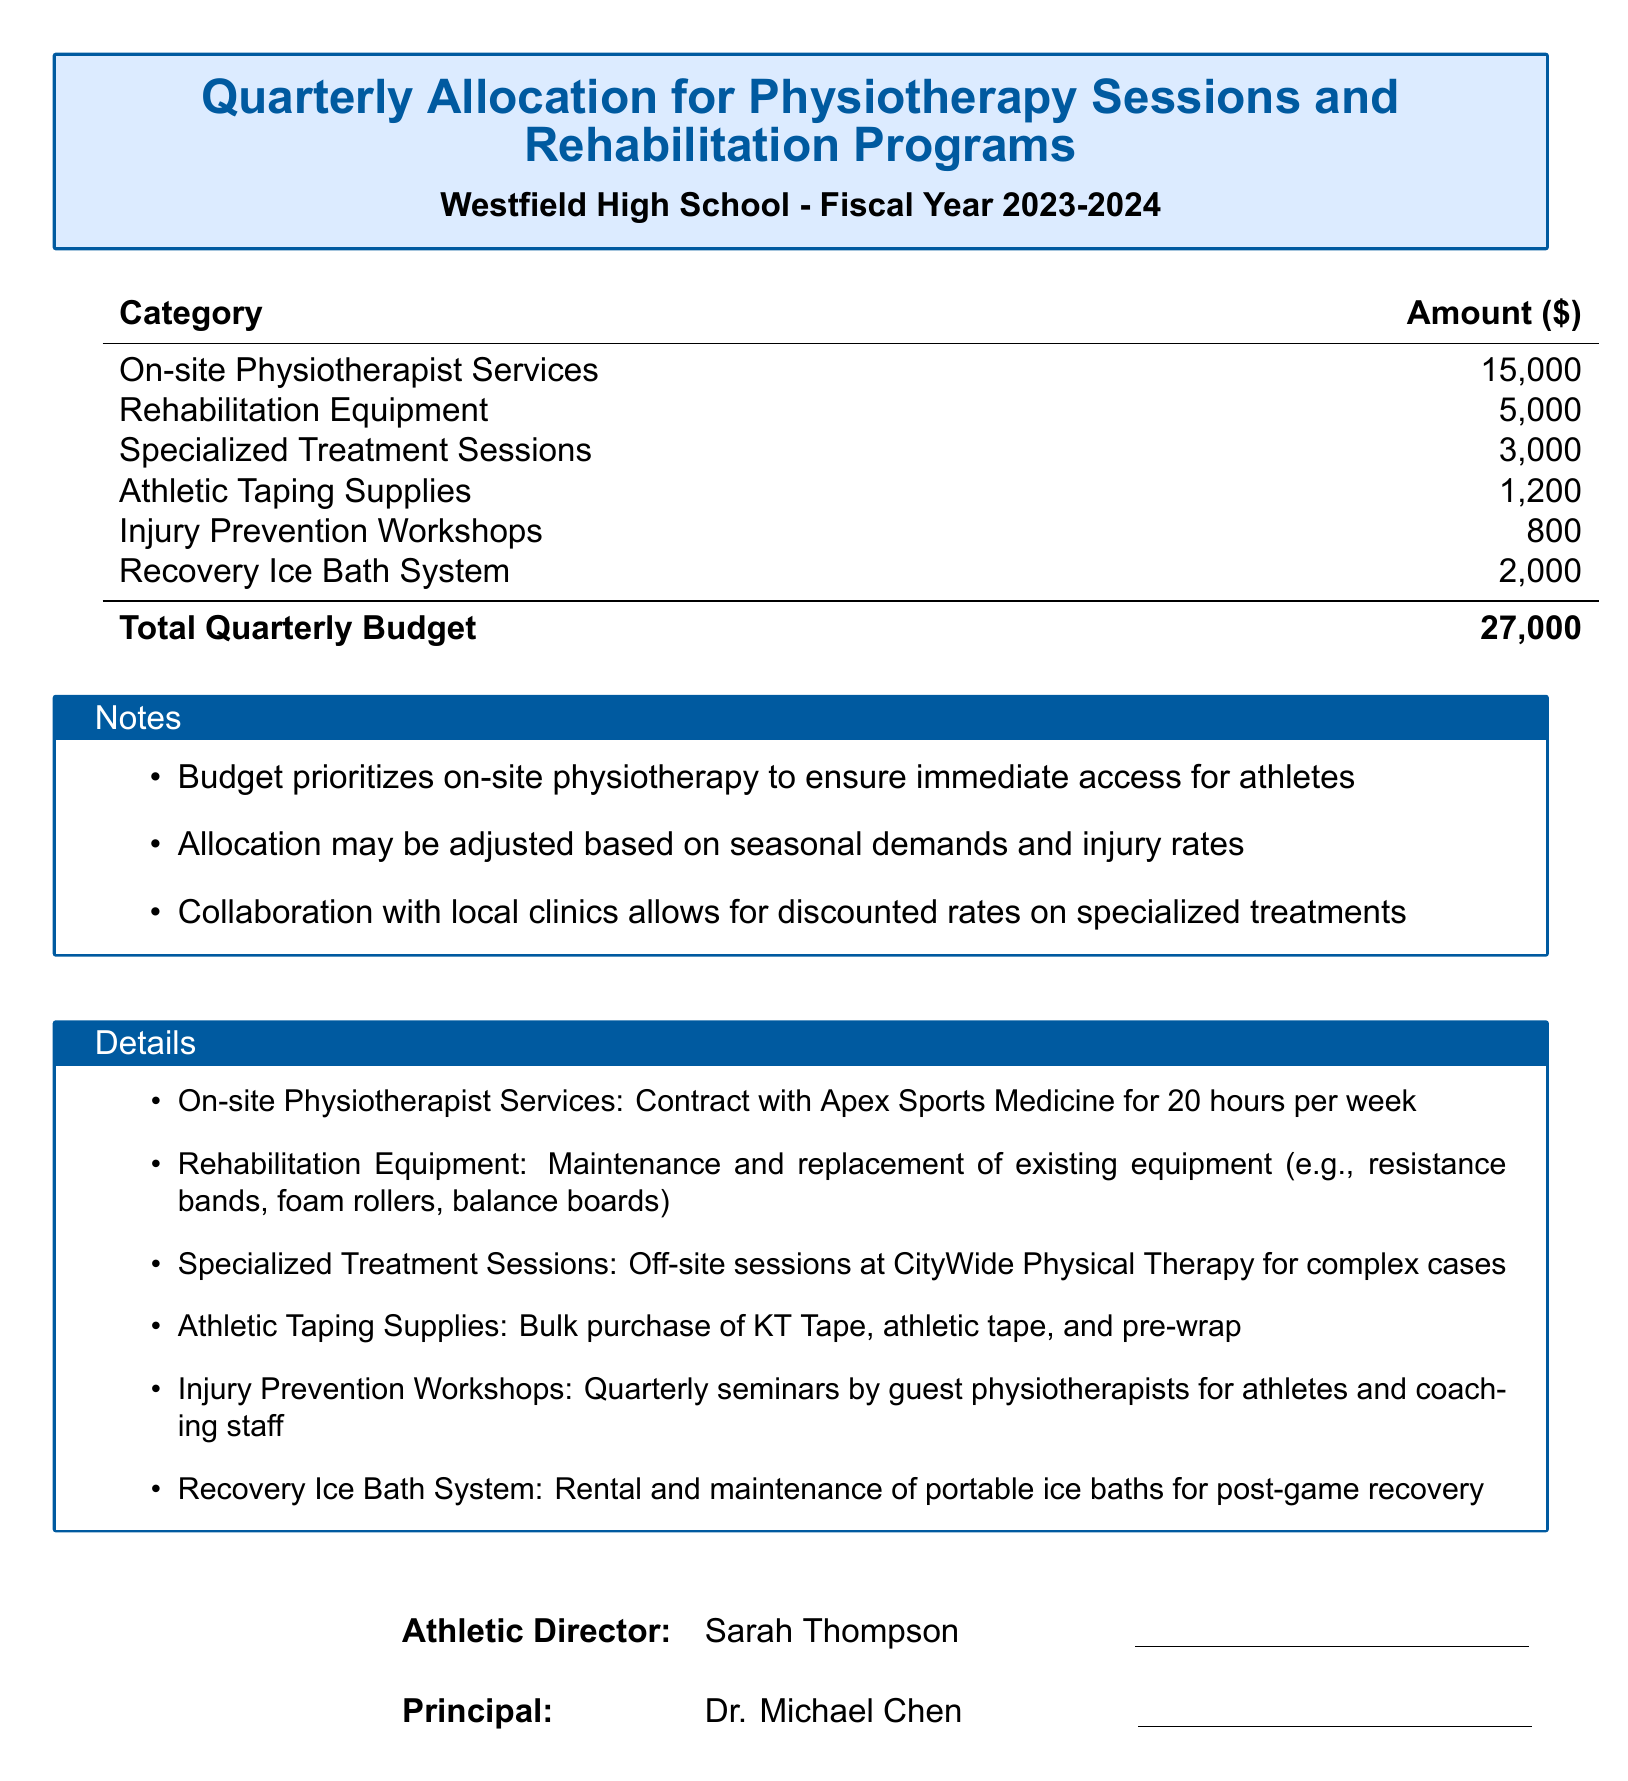what is the total quarterly budget? The total quarterly budget is the sum of all allocations provided in the document.
Answer: 27,000 who is the athletic director? The document specifies the athletic director's name at the bottom in the signature section.
Answer: Sarah Thompson how much is allocated for rehabilitation equipment? The document lists specific amounts allocated to each category, including rehabilitation equipment.
Answer: 5,000 what is included in injury prevention workshops? The document mentions quarterly seminars by guest physiotherapists for this category.
Answer: Seminars how many hours per week does the on-site physiotherapist work? The document specifies the contractual hours for the physiotherapy services provided.
Answer: 20 hours what is the cost for specialized treatment sessions? The document clearly states the amount allocated for specialized treatment sessions.
Answer: 3,000 where are specialized treatment sessions conducted? The document refers to an organization that provides these off-site services.
Answer: CityWide Physical Therapy how much is required for athletic taping supplies? The document specifies the budget allocated for athletic taping supplies.
Answer: 1,200 what is the purpose of the recovery ice bath system? The document describes the system's role in aiding post-game recovery for athletes.
Answer: Recovery 